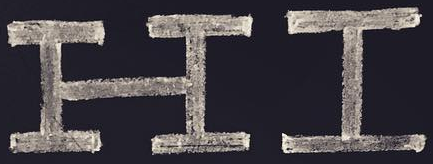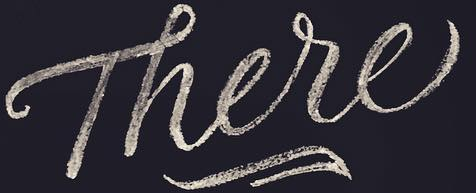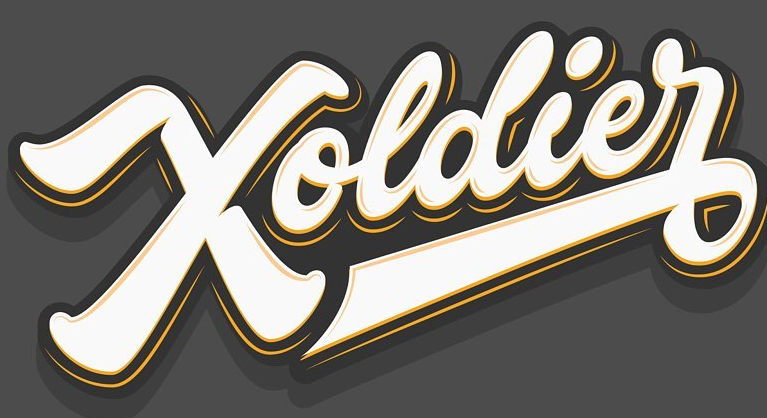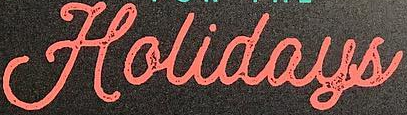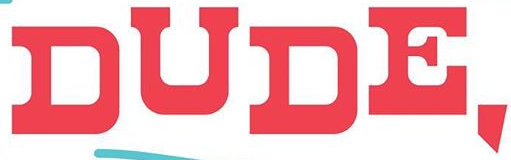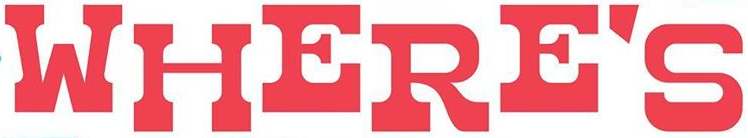Identify the words shown in these images in order, separated by a semicolon. HI; There; Xoldier; Holidays; DUDE,; WHERE'S 